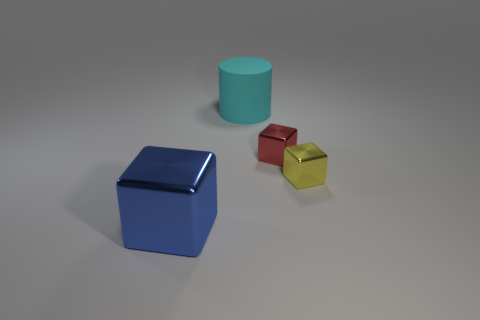What is the color of the object that is in front of the red thing and to the right of the blue metal cube?
Your answer should be very brief. Yellow. What is the shape of the shiny thing that is on the left side of the matte thing?
Offer a very short reply. Cube. There is a blue object that is made of the same material as the tiny yellow thing; what shape is it?
Give a very brief answer. Cube. How many metal things are either cyan cylinders or large brown balls?
Keep it short and to the point. 0. How many big metal cubes are left of the cube left of the large object behind the big blue shiny object?
Provide a succinct answer. 0. There is a block behind the small yellow cube; does it have the same size as the metal object in front of the small yellow object?
Ensure brevity in your answer.  No. How many large things are matte cylinders or red metallic balls?
Your answer should be compact. 1. What material is the large cyan cylinder?
Your response must be concise. Rubber. What is the thing that is both on the left side of the red block and behind the blue cube made of?
Your answer should be very brief. Rubber. Do the large rubber cylinder and the block that is on the left side of the big cyan matte cylinder have the same color?
Provide a succinct answer. No. 